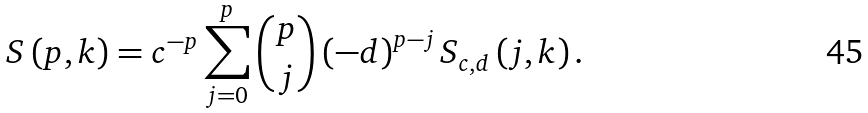Convert formula to latex. <formula><loc_0><loc_0><loc_500><loc_500>S \left ( p , k \right ) = c ^ { - p } \sum _ { j = 0 } ^ { p } \binom { p } { j } \left ( - d \right ) ^ { p - j } S _ { c , d } \left ( j , k \right ) .</formula> 